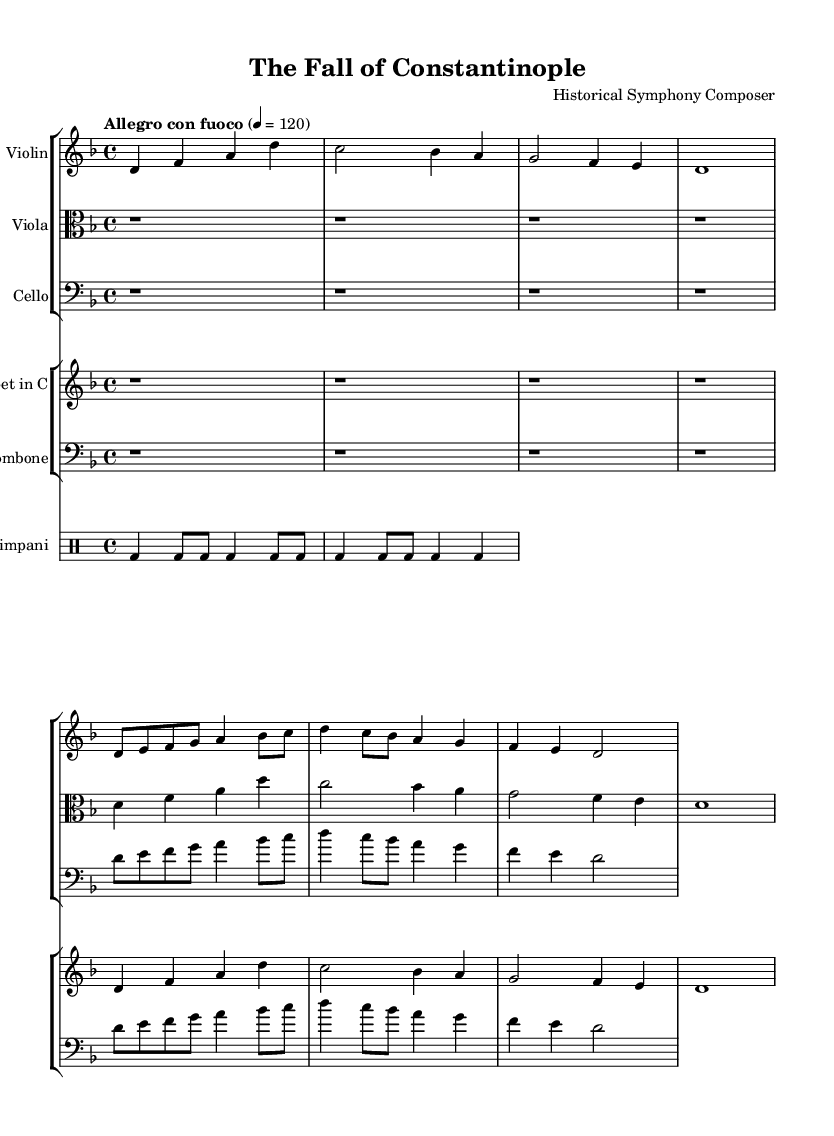What is the title of this composition? The title is indicated in the header section of the sheet music, which states "The Fall of Constantinople."
Answer: The Fall of Constantinople What is the composer’s name? The composer’s name is listed in the header section of the sheet music as "Historical Symphony Composer."
Answer: Historical Symphony Composer What is the key signature of this music? The key signature is mentioned in the global variable; it resembles two flats, indicating D minor.
Answer: D minor What is the time signature of the piece? The time signature is found in the global settings, shown as 4/4, meaning four beats per measure.
Answer: 4/4 What is the tempo marking? The tempo marking is stated as "Allegro con fuoco" and a quarter note equals 120, indicating a lively tempo.
Answer: Allegro con fuoco Which instruments are included in the orchestration? The orchestration is indicated in the score and includes violin, viola, cello, trumpet, trombone, and timpani.
Answer: Violin, viola, cello, trumpet, trombone, timpani How many times does theme A appear in this piece? By analyzing the score notation, theme A is played by the violin and trumpet, appearing twice in the piece.
Answer: Twice 